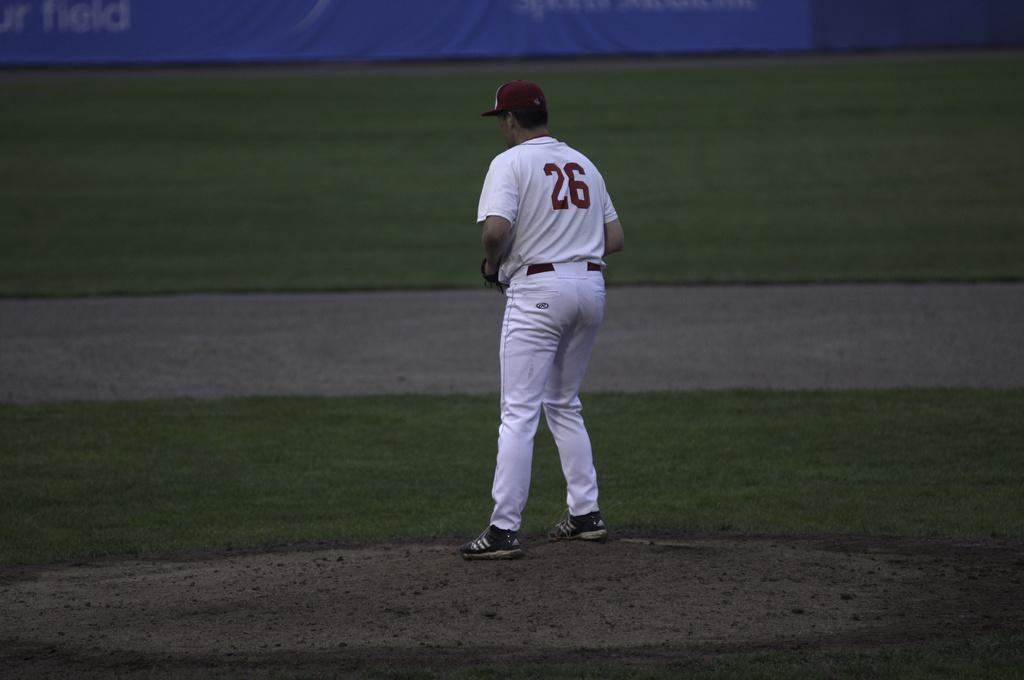<image>
Present a compact description of the photo's key features. Man wearing a white jersey with the number 26 on it standing on the field. 